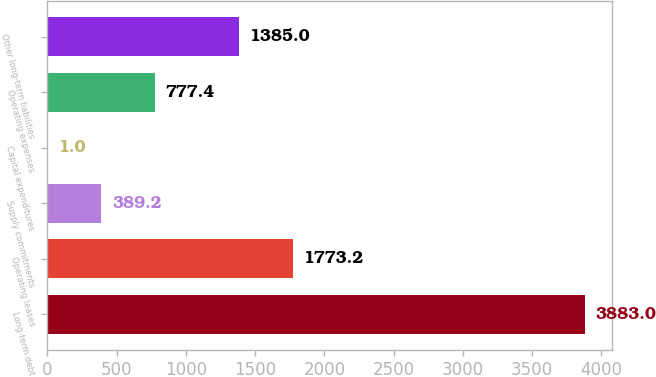Convert chart. <chart><loc_0><loc_0><loc_500><loc_500><bar_chart><fcel>Long-term debt<fcel>Operating leases<fcel>Supply commitments<fcel>Capital expenditures<fcel>Operating expenses<fcel>Other long-term liabilities<nl><fcel>3883<fcel>1773.2<fcel>389.2<fcel>1<fcel>777.4<fcel>1385<nl></chart> 